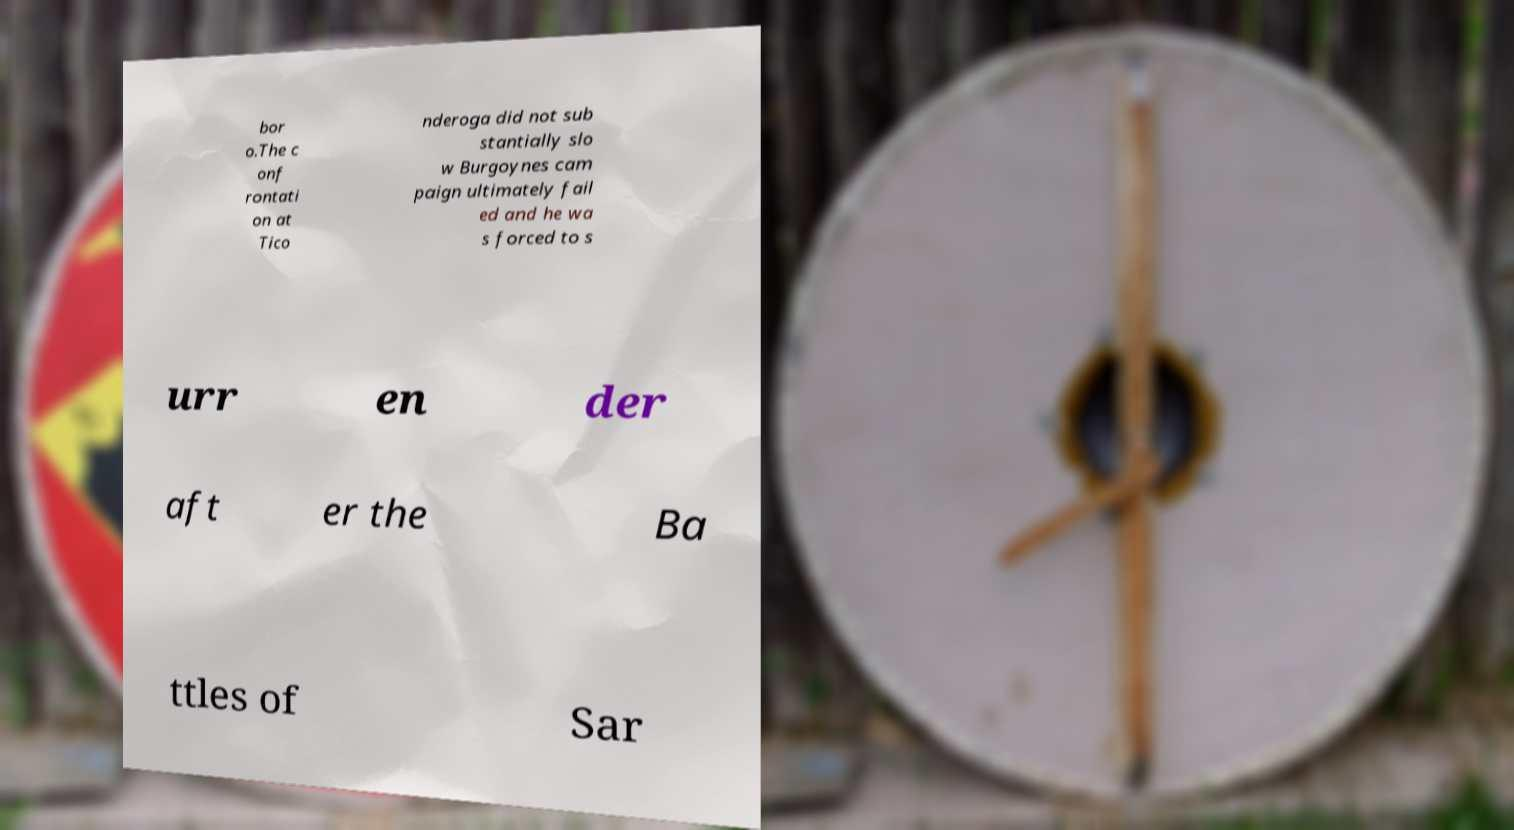For documentation purposes, I need the text within this image transcribed. Could you provide that? bor o.The c onf rontati on at Tico nderoga did not sub stantially slo w Burgoynes cam paign ultimately fail ed and he wa s forced to s urr en der aft er the Ba ttles of Sar 